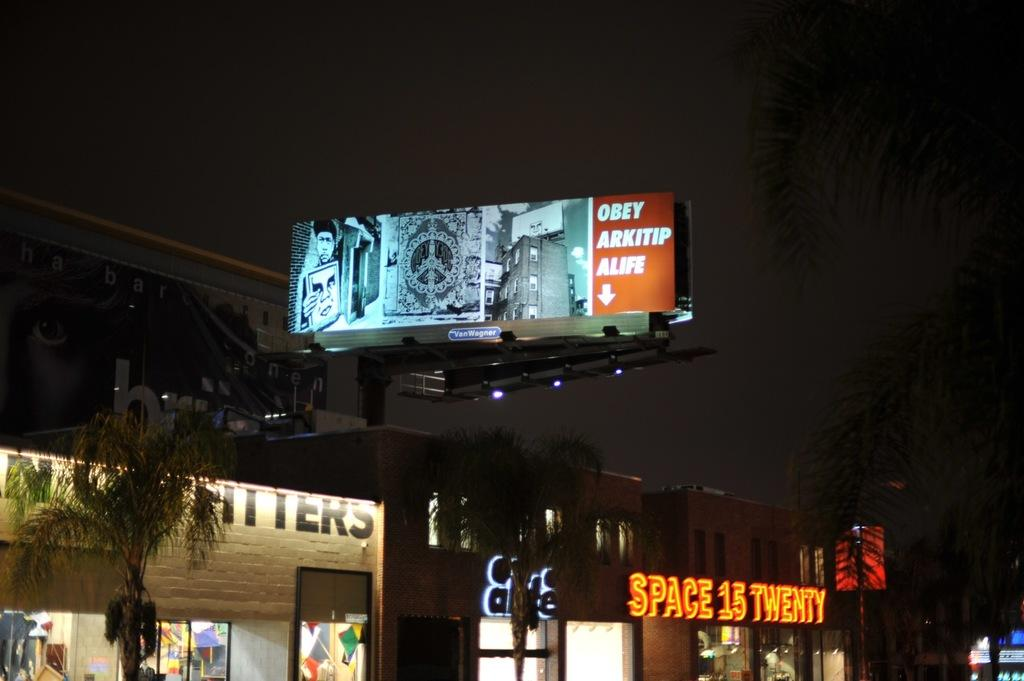<image>
Render a clear and concise summary of the photo. Under a lighted billboard is a building with the sign reading SPACE 15 TWENTY. 